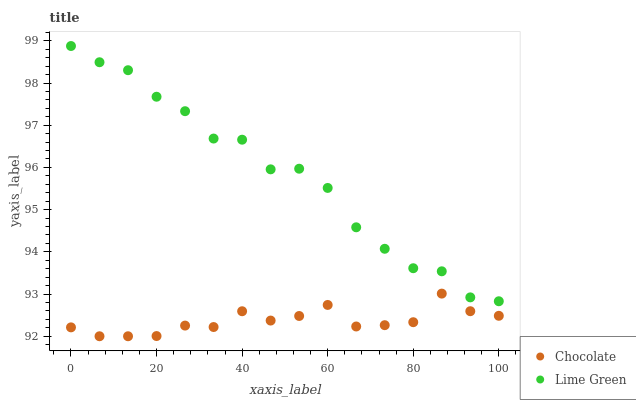Does Chocolate have the minimum area under the curve?
Answer yes or no. Yes. Does Lime Green have the maximum area under the curve?
Answer yes or no. Yes. Does Chocolate have the maximum area under the curve?
Answer yes or no. No. Is Chocolate the smoothest?
Answer yes or no. Yes. Is Lime Green the roughest?
Answer yes or no. Yes. Is Chocolate the roughest?
Answer yes or no. No. Does Chocolate have the lowest value?
Answer yes or no. Yes. Does Lime Green have the highest value?
Answer yes or no. Yes. Does Chocolate have the highest value?
Answer yes or no. No. Is Chocolate less than Lime Green?
Answer yes or no. Yes. Is Lime Green greater than Chocolate?
Answer yes or no. Yes. Does Chocolate intersect Lime Green?
Answer yes or no. No. 